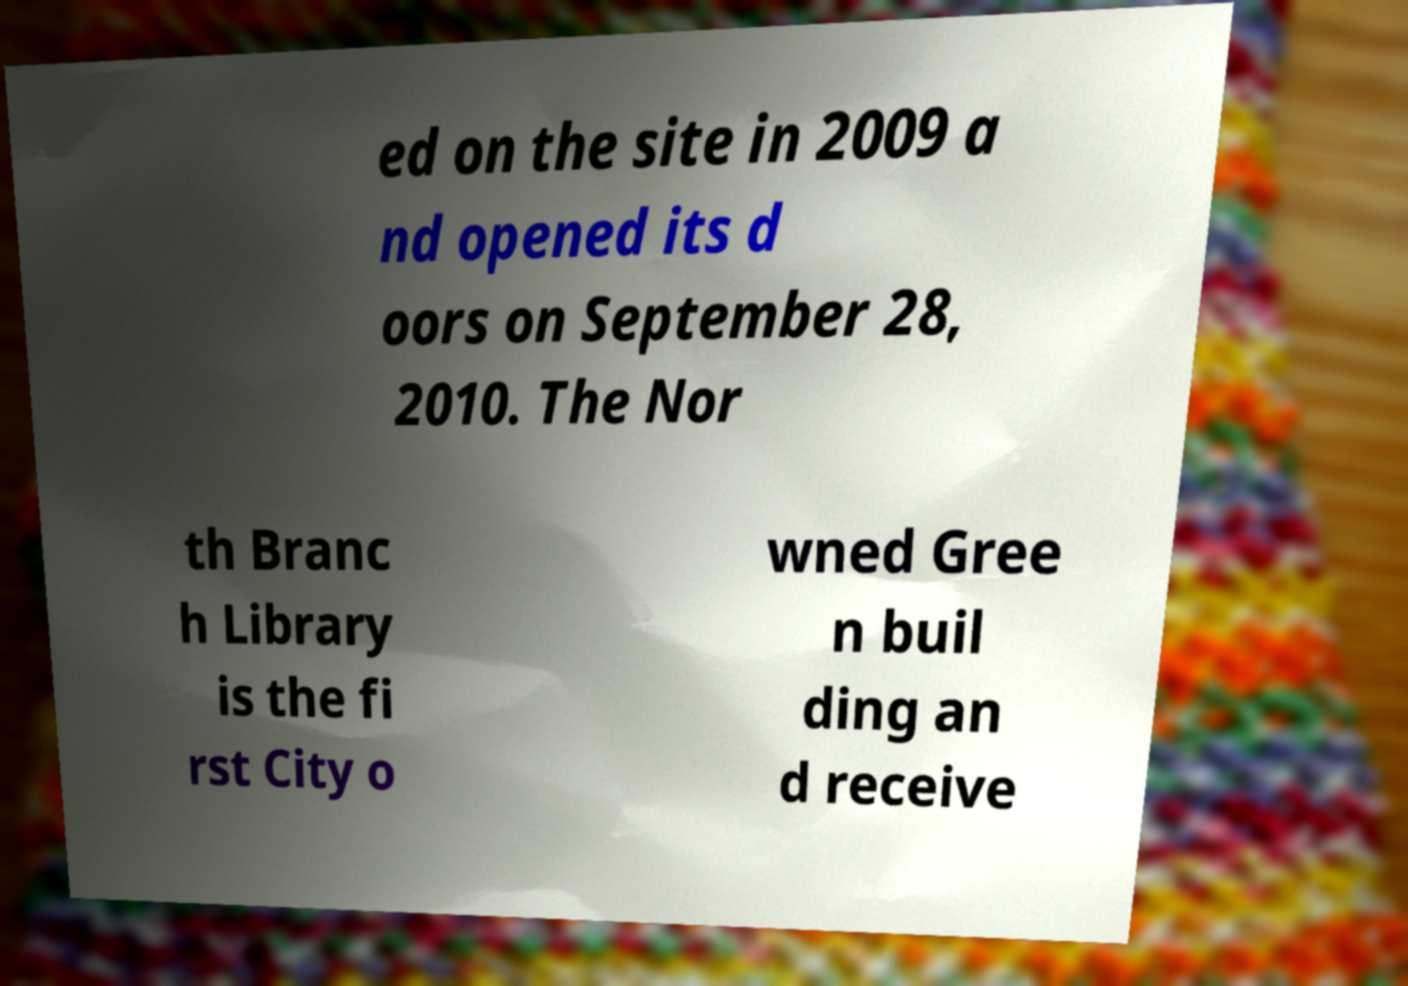I need the written content from this picture converted into text. Can you do that? ed on the site in 2009 a nd opened its d oors on September 28, 2010. The Nor th Branc h Library is the fi rst City o wned Gree n buil ding an d receive 